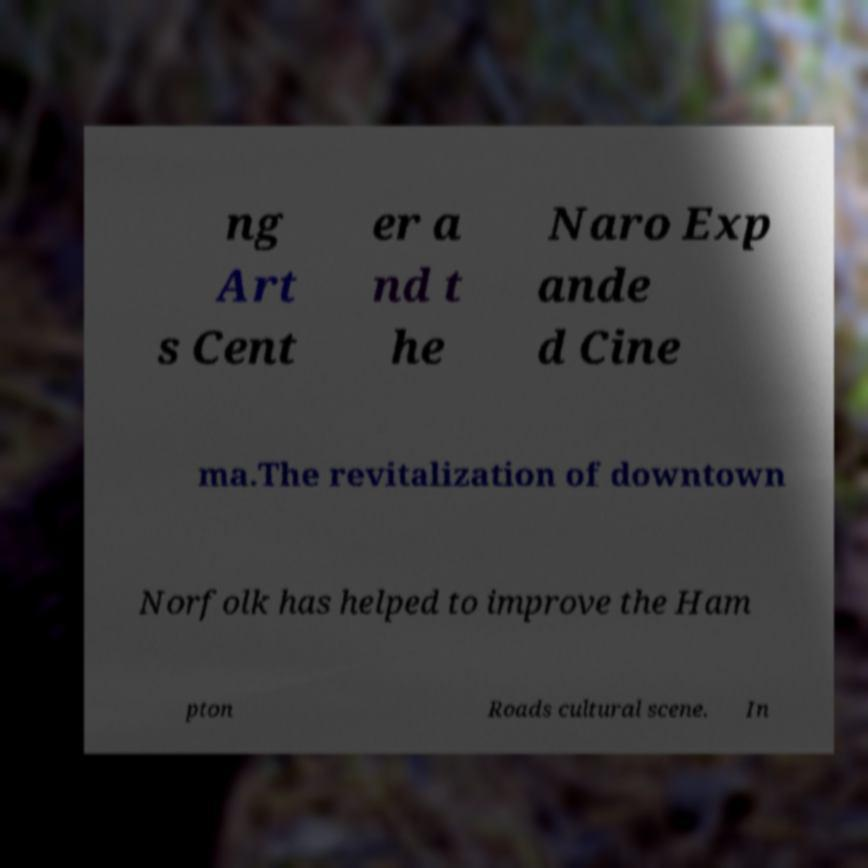There's text embedded in this image that I need extracted. Can you transcribe it verbatim? ng Art s Cent er a nd t he Naro Exp ande d Cine ma.The revitalization of downtown Norfolk has helped to improve the Ham pton Roads cultural scene. In 